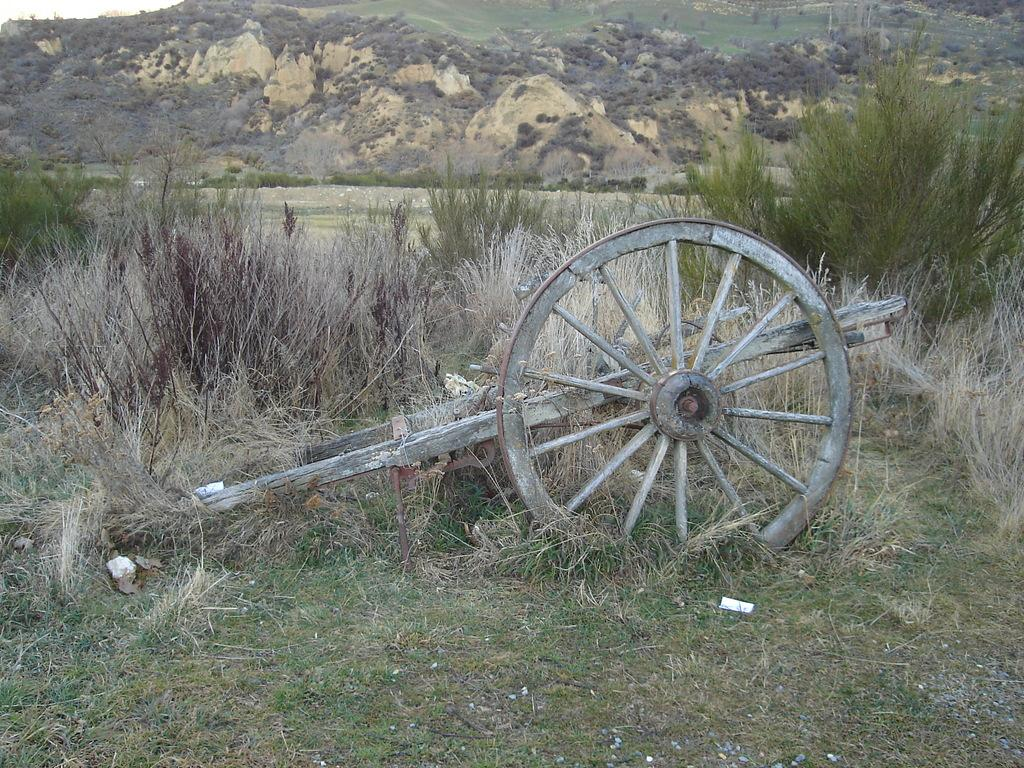What is the main object in the image? There is a cart in the image. What type of terrain is visible in the image? There is grass in the image. What other natural elements can be seen in the image? There are plants in the image. What can be seen in the distance in the image? There are mountains visible in the background of the image. What hobbies does the cart have in the image? The cart is an inanimate object and does not have hobbies. 